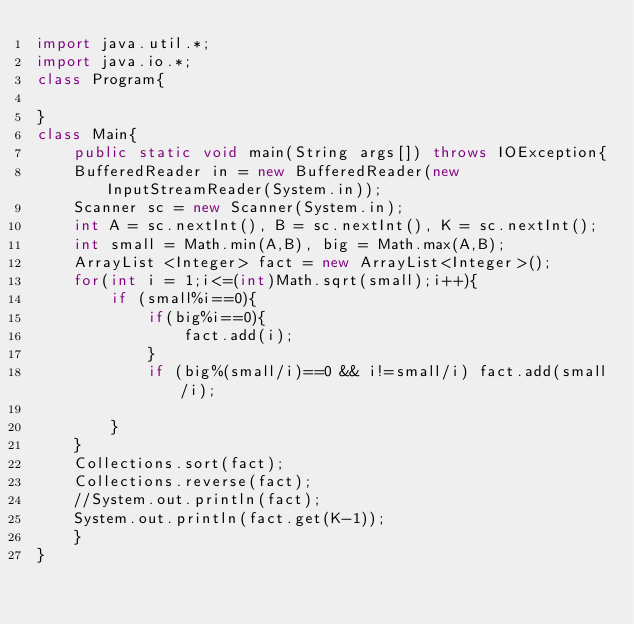Convert code to text. <code><loc_0><loc_0><loc_500><loc_500><_Java_>import java.util.*;
import java.io.*;
class Program{

}
class Main{
    public static void main(String args[]) throws IOException{
    BufferedReader in = new BufferedReader(new InputStreamReader(System.in));
    Scanner sc = new Scanner(System.in);
    int A = sc.nextInt(), B = sc.nextInt(), K = sc.nextInt();
    int small = Math.min(A,B), big = Math.max(A,B);
    ArrayList <Integer> fact = new ArrayList<Integer>();
    for(int i = 1;i<=(int)Math.sqrt(small);i++){
        if (small%i==0){
            if(big%i==0){
                fact.add(i);
            }
            if (big%(small/i)==0 && i!=small/i) fact.add(small/i);
            
        }
    }
    Collections.sort(fact);
    Collections.reverse(fact);
    //System.out.println(fact);
    System.out.println(fact.get(K-1));
    }
}

</code> 